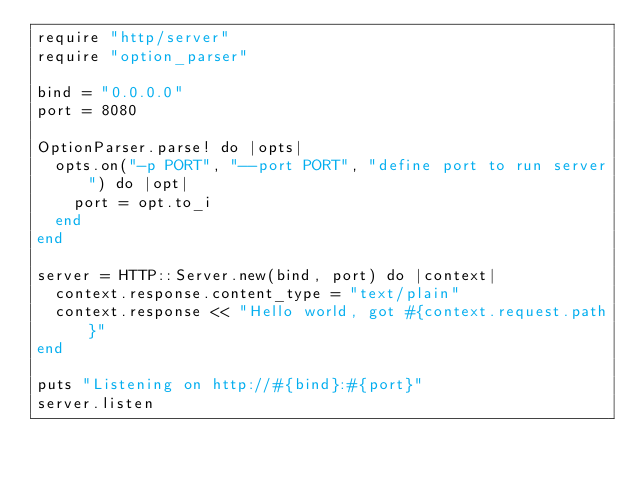<code> <loc_0><loc_0><loc_500><loc_500><_Crystal_>require "http/server"
require "option_parser"

bind = "0.0.0.0"
port = 8080

OptionParser.parse! do |opts|
  opts.on("-p PORT", "--port PORT", "define port to run server") do |opt|
    port = opt.to_i
  end
end

server = HTTP::Server.new(bind, port) do |context|
  context.response.content_type = "text/plain"
  context.response << "Hello world, got #{context.request.path}"
end

puts "Listening on http://#{bind}:#{port}"
server.listen
</code> 